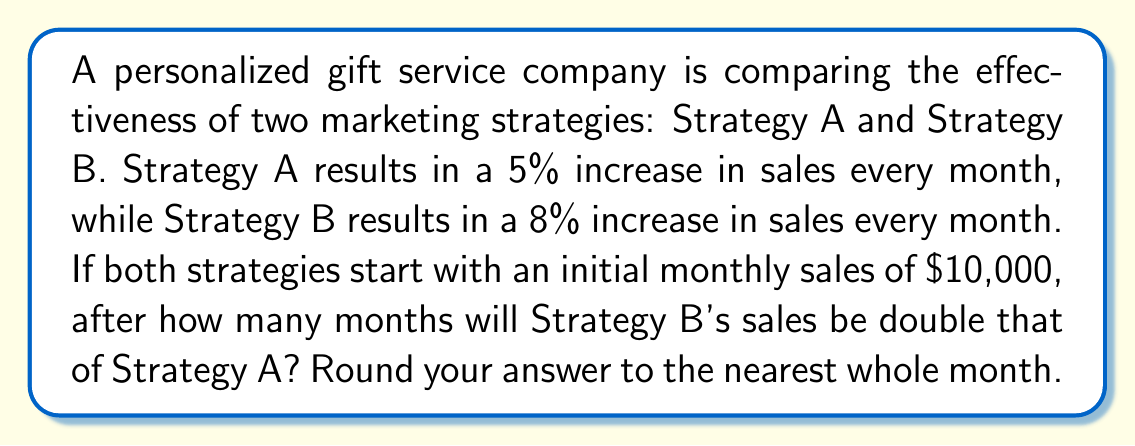Could you help me with this problem? Let's approach this step-by-step:

1) Let $x$ be the number of months.

2) For Strategy A, after $x$ months, the sales will be:
   $10000 \cdot (1.05)^x$

3) For Strategy B, after $x$ months, the sales will be:
   $10000 \cdot (1.08)^x$

4) We want to find when Strategy B's sales are double Strategy A's:
   $10000 \cdot (1.08)^x = 2 \cdot (10000 \cdot (1.05)^x)$

5) Simplify:
   $(1.08)^x = 2 \cdot (1.05)^x$

6) Take the logarithm of both sides:
   $x \cdot \log(1.08) = \log(2) + x \cdot \log(1.05)$

7) Rearrange:
   $x \cdot (\log(1.08) - \log(1.05)) = \log(2)$

8) Solve for $x$:
   $x = \frac{\log(2)}{\log(1.08) - \log(1.05)}$

9) Calculate:
   $x \approx 17.67$

10) Round to the nearest whole month:
    $x = 18$
Answer: 18 months 